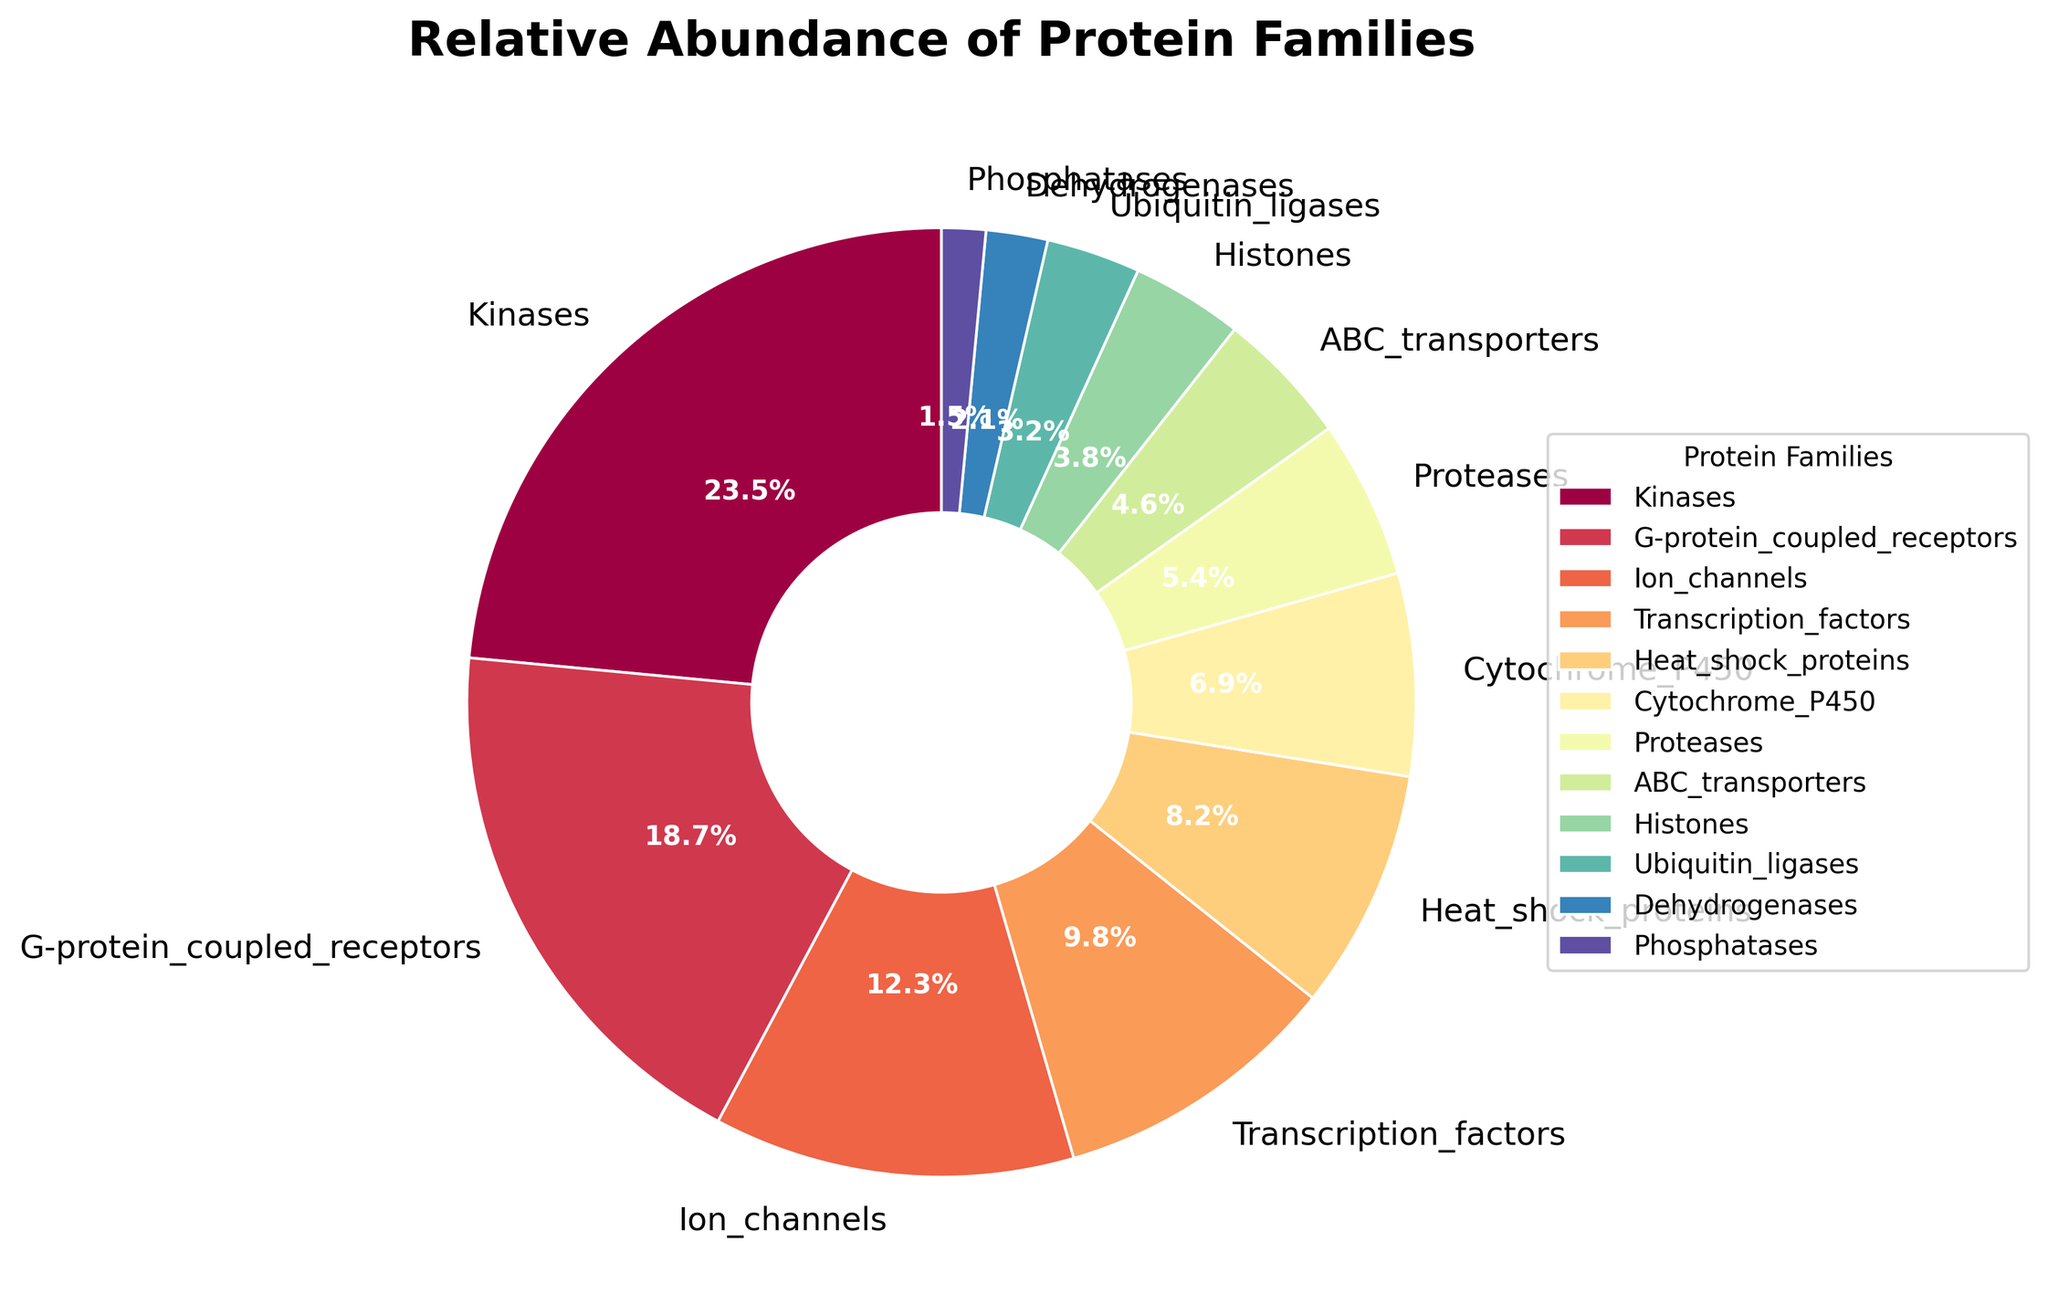What's the most abundant protein family in the organism? The largest slice in the pie chart indicates the most abundant protein family. From the chart, the largest slice is labeled as "Kinases" with a 23.5% relative abundance.
Answer: Kinases Which protein family has a relative abundance close to 5%? The slices of the pie chart show the relative abundances of different protein families. Observing the slices, "ABC_transporters" has a relative abundance of 4.6%, which is closest to 5%.
Answer: ABC_transporters What is the combined relative abundance of Transcription_factors and Heat_shock_proteins? The slices for "Transcription_factors" and "Heat_shock_proteins" show relative abundances of 9.8% and 8.2%, respectively. Adding them together: 9.8% + 8.2% = 18.0%.
Answer: 18.0% How does the relative abundance of G-protein_coupled_receptors compare to that of Ion_channels? The slices for "G-protein_coupled_receptors" and "Ion_channels" have relative abundances of 18.7% and 12.3%, respectively. Comparing the two: 18.7% > 12.3%.
Answer: G-protein_coupled_receptors has a higher relative abundance than Ion_channels What is the smallest protein family by relative abundance? The smallest slice on the pie chart represents the protein family with the lowest relative abundance. "Phosphatases" has the smallest slice with 1.5%.
Answer: Phosphatases Among the protein families listed, which one has a relative abundance slightly below 7%? The slices show relative abundances of various protein families. "Cytochrome_P450" has a relative abundance of 6.9%, which is just below 7%.
Answer: Cytochrome_P450 Which protein families together make up approximately 10% of the relative abundance? The pie chart reveals different relative abundances. "Ubiquitin_ligases" (3.2%) + "Dehydrogenases" (2.1%) + "Phosphatases" (1.5%) = 6.8%, and "Histones" (3.8%) + "Phosphatases" (1.5%) = 5.3%, so none of the combinations precisely sum up to 10%. Similarly, assessing other combinations will confirm there are no exact pairs but ABC_transporters (4.6%) and Proteases (5.4%) have a combined relative abundance that sums up closely to 10%.
Answer: ABC_transporters and Proteases What is the median relative abundance for all protein families listed? Arranging the values in ascending order: 1.5%, 2.1%, 3.2%, 3.8%, 4.6%, 5.4%, 6.9%, 8.2%, 9.8%, 12.3%, 18.7%, 23.5%. Since there are 12 values, the median is the average of the 6th and 7th values: (5.4% + 6.9%)/2 = 6.15%.
Answer: 6.15% What is the second least abundant protein family, based on relative abundance? Observing the slices from the smallest slice upwards: the second smallest slice belongs to "Dehydrogenases" with a percentage of 2.1%.
Answer: Dehydrogenases Which has a higher relative abundance, Transcription_factors or Heat_shock_proteins? The slices for "Transcription_factors" and "Heat_shock_proteins" show 9.8% and 8.2%, respectively. Comparing these values: 9.8% > 8.2%.
Answer: Transcription_factors 